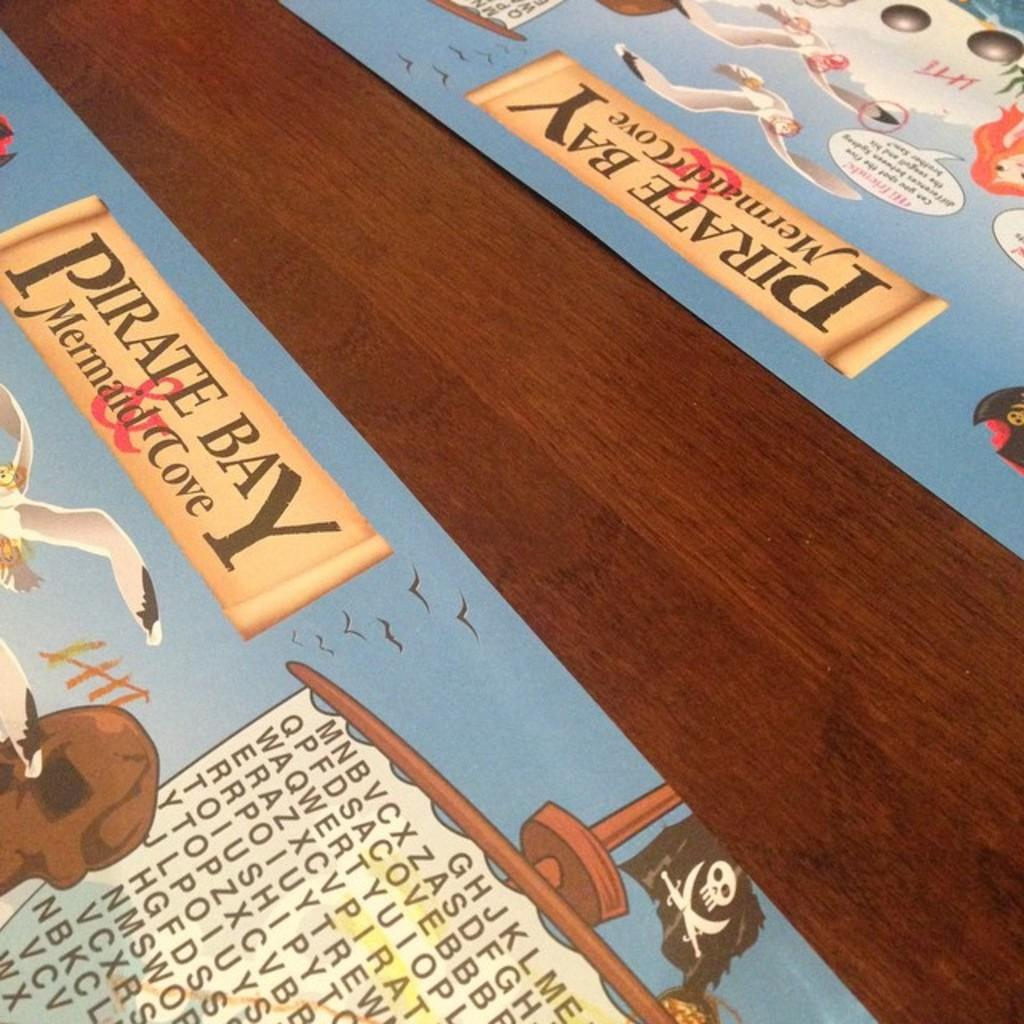<image>
Create a compact narrative representing the image presented. Two placemats with the words Pirate Bay and Mermaid Cove on them are on a wooden table. 